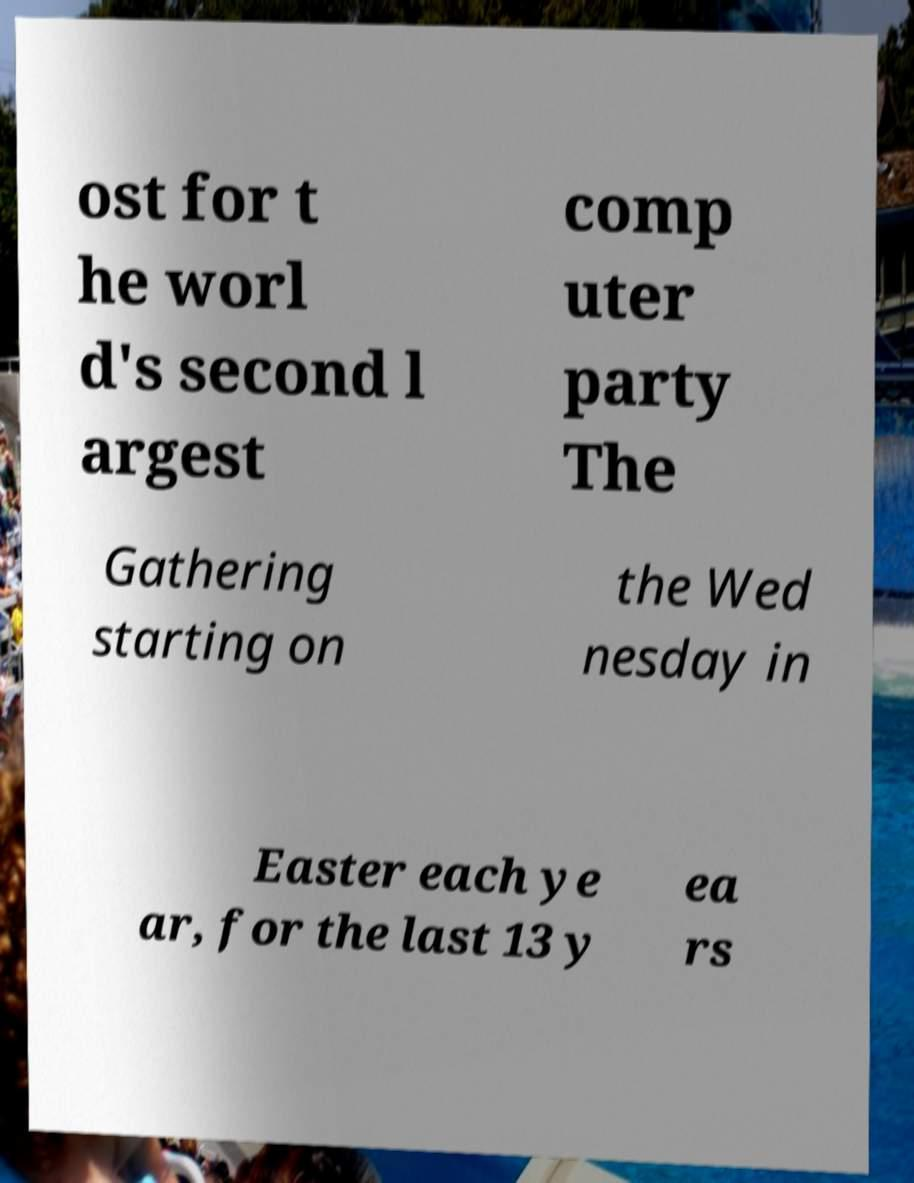Can you accurately transcribe the text from the provided image for me? ost for t he worl d's second l argest comp uter party The Gathering starting on the Wed nesday in Easter each ye ar, for the last 13 y ea rs 